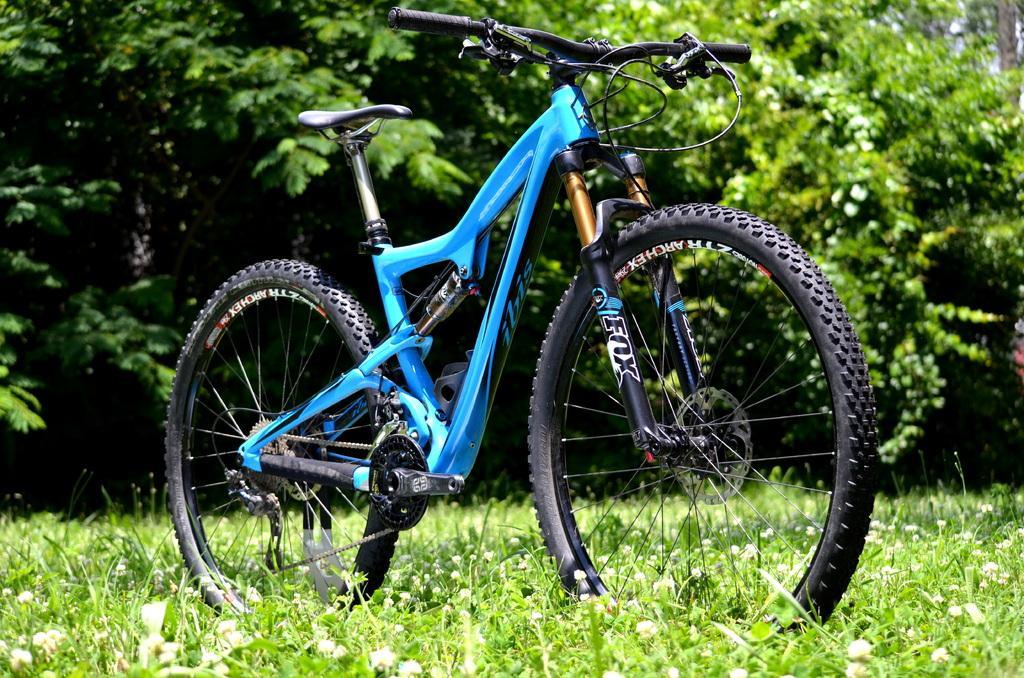Describe this image in one or two sentences. In the center of the image there is a bicycle on the grass. In the background we can see trees. 